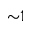<formula> <loc_0><loc_0><loc_500><loc_500>{ \sim } 1</formula> 